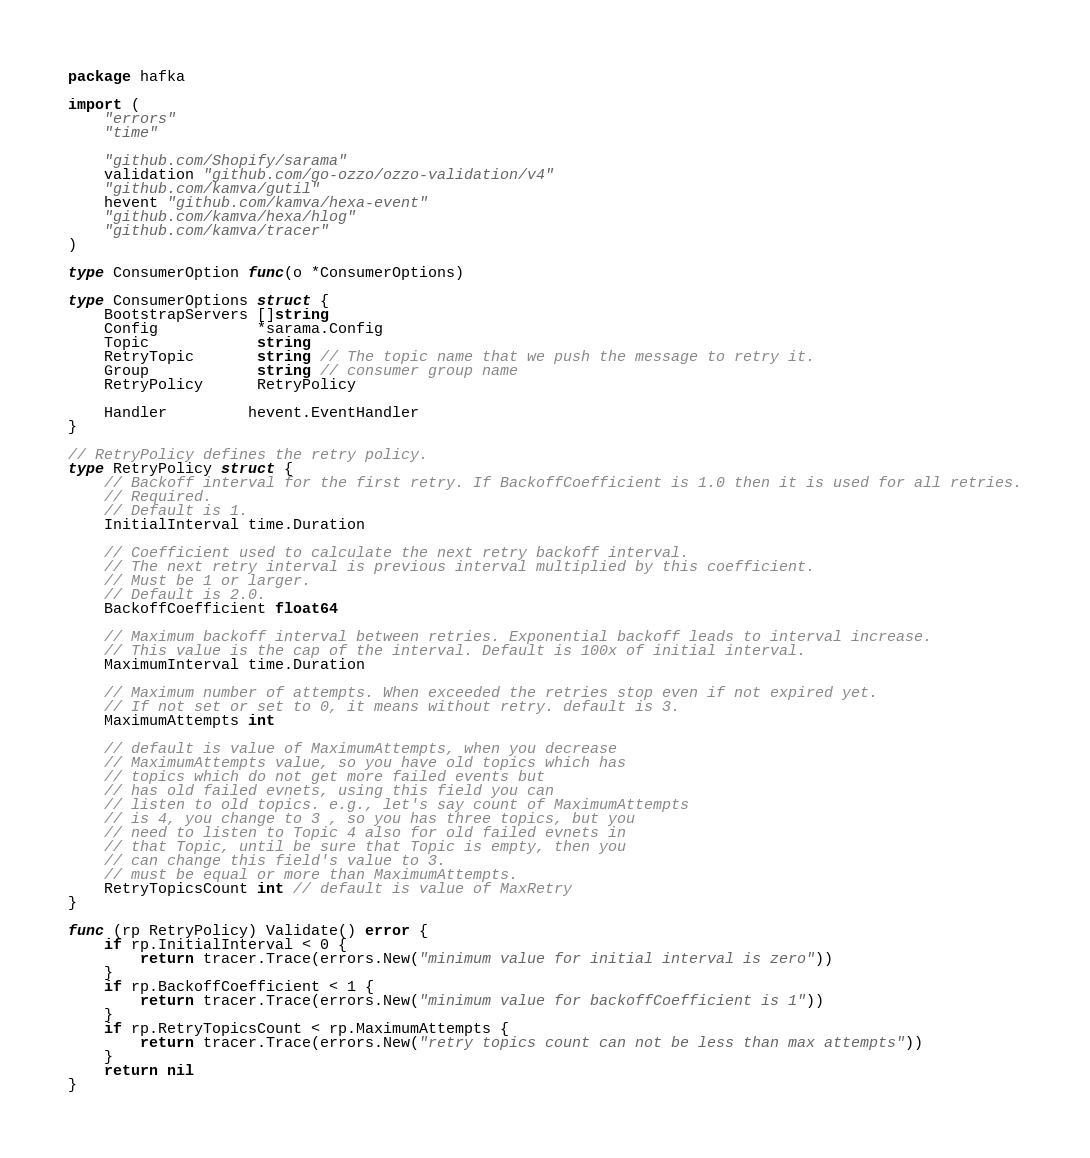Convert code to text. <code><loc_0><loc_0><loc_500><loc_500><_Go_>package hafka

import (
	"errors"
	"time"

	"github.com/Shopify/sarama"
	validation "github.com/go-ozzo/ozzo-validation/v4"
	"github.com/kamva/gutil"
	hevent "github.com/kamva/hexa-event"
	"github.com/kamva/hexa/hlog"
	"github.com/kamva/tracer"
)

type ConsumerOption func(o *ConsumerOptions)

type ConsumerOptions struct {
	BootstrapServers []string
	Config           *sarama.Config
	Topic            string
	RetryTopic       string // The topic name that we push the message to retry it.
	Group            string // consumer group name
	RetryPolicy      RetryPolicy

	Handler         hevent.EventHandler
}

// RetryPolicy defines the retry policy.
type RetryPolicy struct {
	// Backoff interval for the first retry. If BackoffCoefficient is 1.0 then it is used for all retries.
	// Required.
	// Default is 1.
	InitialInterval time.Duration

	// Coefficient used to calculate the next retry backoff interval.
	// The next retry interval is previous interval multiplied by this coefficient.
	// Must be 1 or larger.
	// Default is 2.0.
	BackoffCoefficient float64

	// Maximum backoff interval between retries. Exponential backoff leads to interval increase.
	// This value is the cap of the interval. Default is 100x of initial interval.
	MaximumInterval time.Duration

	// Maximum number of attempts. When exceeded the retries stop even if not expired yet.
	// If not set or set to 0, it means without retry. default is 3.
	MaximumAttempts int

	// default is value of MaximumAttempts, when you decrease
	// MaximumAttempts value, so you have old topics which has
	// topics which do not get more failed events but
	// has old failed evnets, using this field you can
	// listen to old topics. e.g., let's say count of MaximumAttempts
	// is 4, you change to 3 , so you has three topics, but you
	// need to listen to Topic 4 also for old failed evnets in
	// that Topic, until be sure that Topic is empty, then you
	// can change this field's value to 3.
	// must be equal or more than MaximumAttempts.
	RetryTopicsCount int // default is value of MaxRetry
}

func (rp RetryPolicy) Validate() error {
	if rp.InitialInterval < 0 {
		return tracer.Trace(errors.New("minimum value for initial interval is zero"))
	}
	if rp.BackoffCoefficient < 1 {
		return tracer.Trace(errors.New("minimum value for backoffCoefficient is 1"))
	}
	if rp.RetryTopicsCount < rp.MaximumAttempts {
		return tracer.Trace(errors.New("retry topics count can not be less than max attempts"))
	}
	return nil
}
</code> 